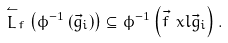<formula> <loc_0><loc_0><loc_500><loc_500>\stackrel { \leftharpoonup } { L } _ { f } \left ( \phi ^ { - 1 } \left ( \vec { g } _ { i } \right ) \right ) \subseteq \phi ^ { - 1 } \left ( \vec { f } \ x l \vec { g } _ { i } \right ) .</formula> 